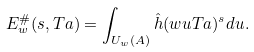<formula> <loc_0><loc_0><loc_500><loc_500>E ^ { \# } _ { w } ( s , T a ) = \int _ { { U _ { w } } ( { A } ) } \hat { h } ( w u T a ) ^ { s } d u .</formula> 